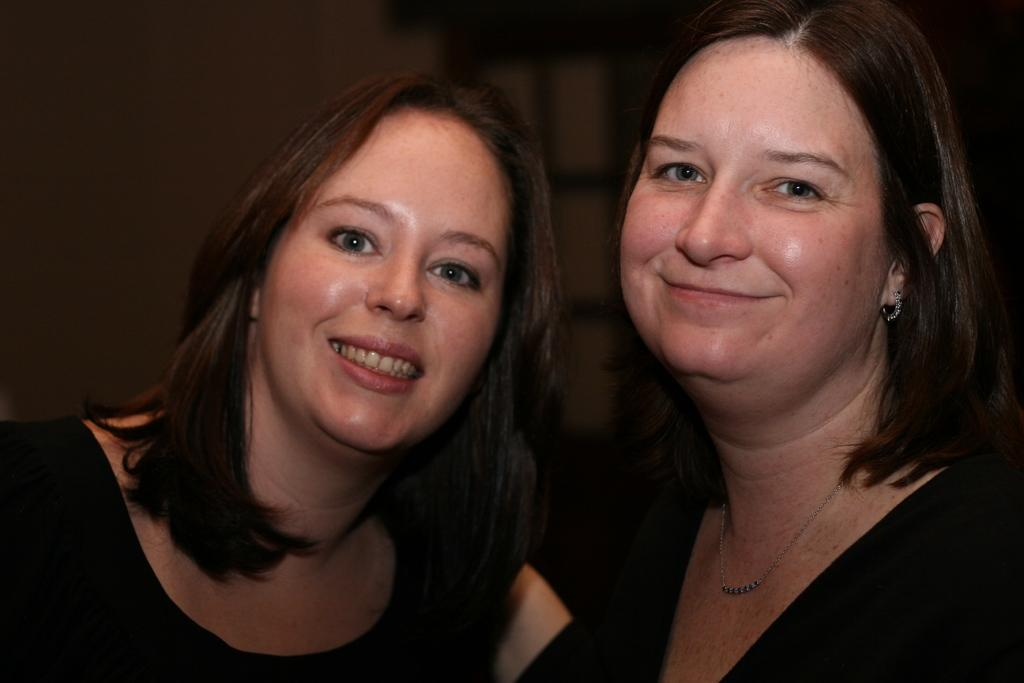How many women are in the image? There are two women in the image. What expressions do the women have? Both women are smiling. What are the women wearing? Both women are wearing black dresses. What type of chicken can be seen in the image? There is no chicken present in the image. How does the spy communicate with the women in the image? There is no spy or any indication of communication in the image. 